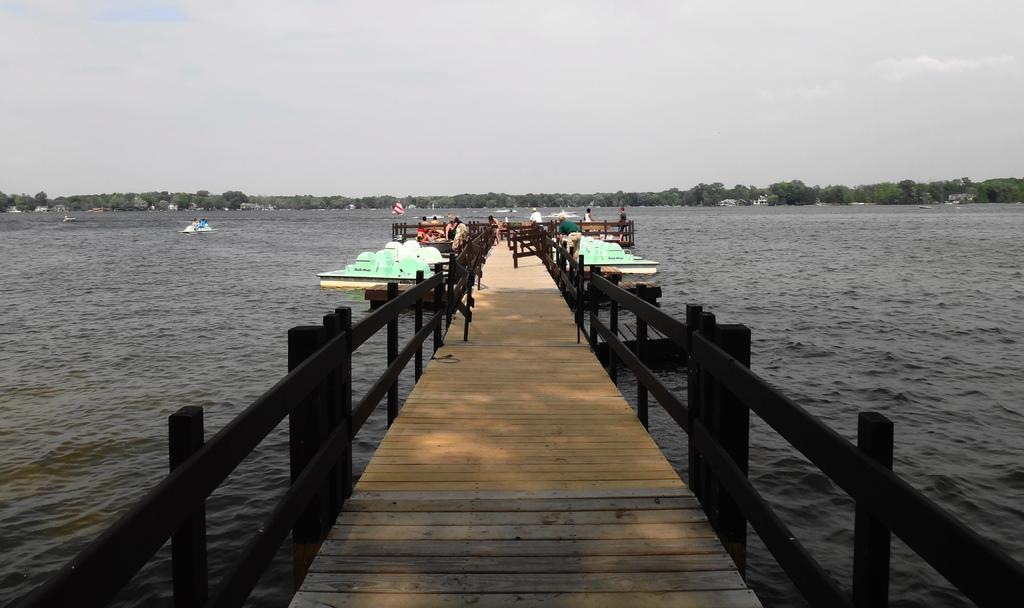What type of vehicles can be seen on the water in the image? There are boats on the river in the image. What type of path is present in the image? There is a wooden path in the image. What feature can be seen along the path in the image? There are railings in the image. Who or what is present in the image? There are people in the image. What type of natural environment is visible in the image? There are trees visible in the image. What part of the natural environment is visible above the trees? The sky is visible in the image. What type of blade is being used by the person in the image? There is no blade visible in the image. What type of property is being sold in the image? There is no property being sold in the image. 